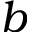<formula> <loc_0><loc_0><loc_500><loc_500>b</formula> 